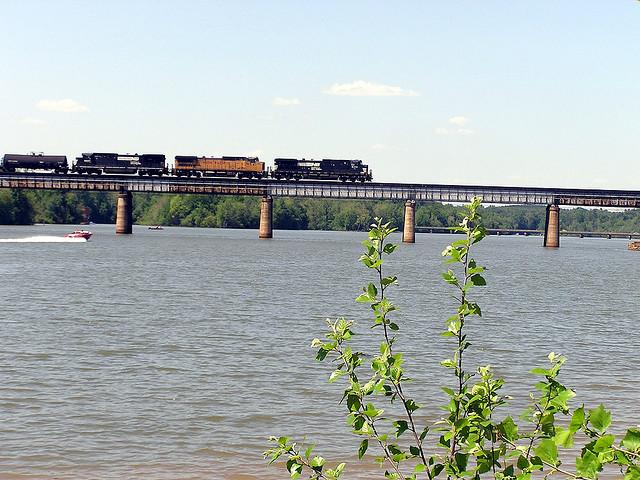Are there trees in the image?
Quick response, please. Yes. Is the water rough?
Quick response, please. No. Is it sunny?
Concise answer only. Yes. 